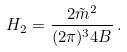<formula> <loc_0><loc_0><loc_500><loc_500>H _ { 2 } = \frac { 2 \tilde { m } ^ { 2 } } { ( 2 \pi ) ^ { 3 } 4 B } \, .</formula> 